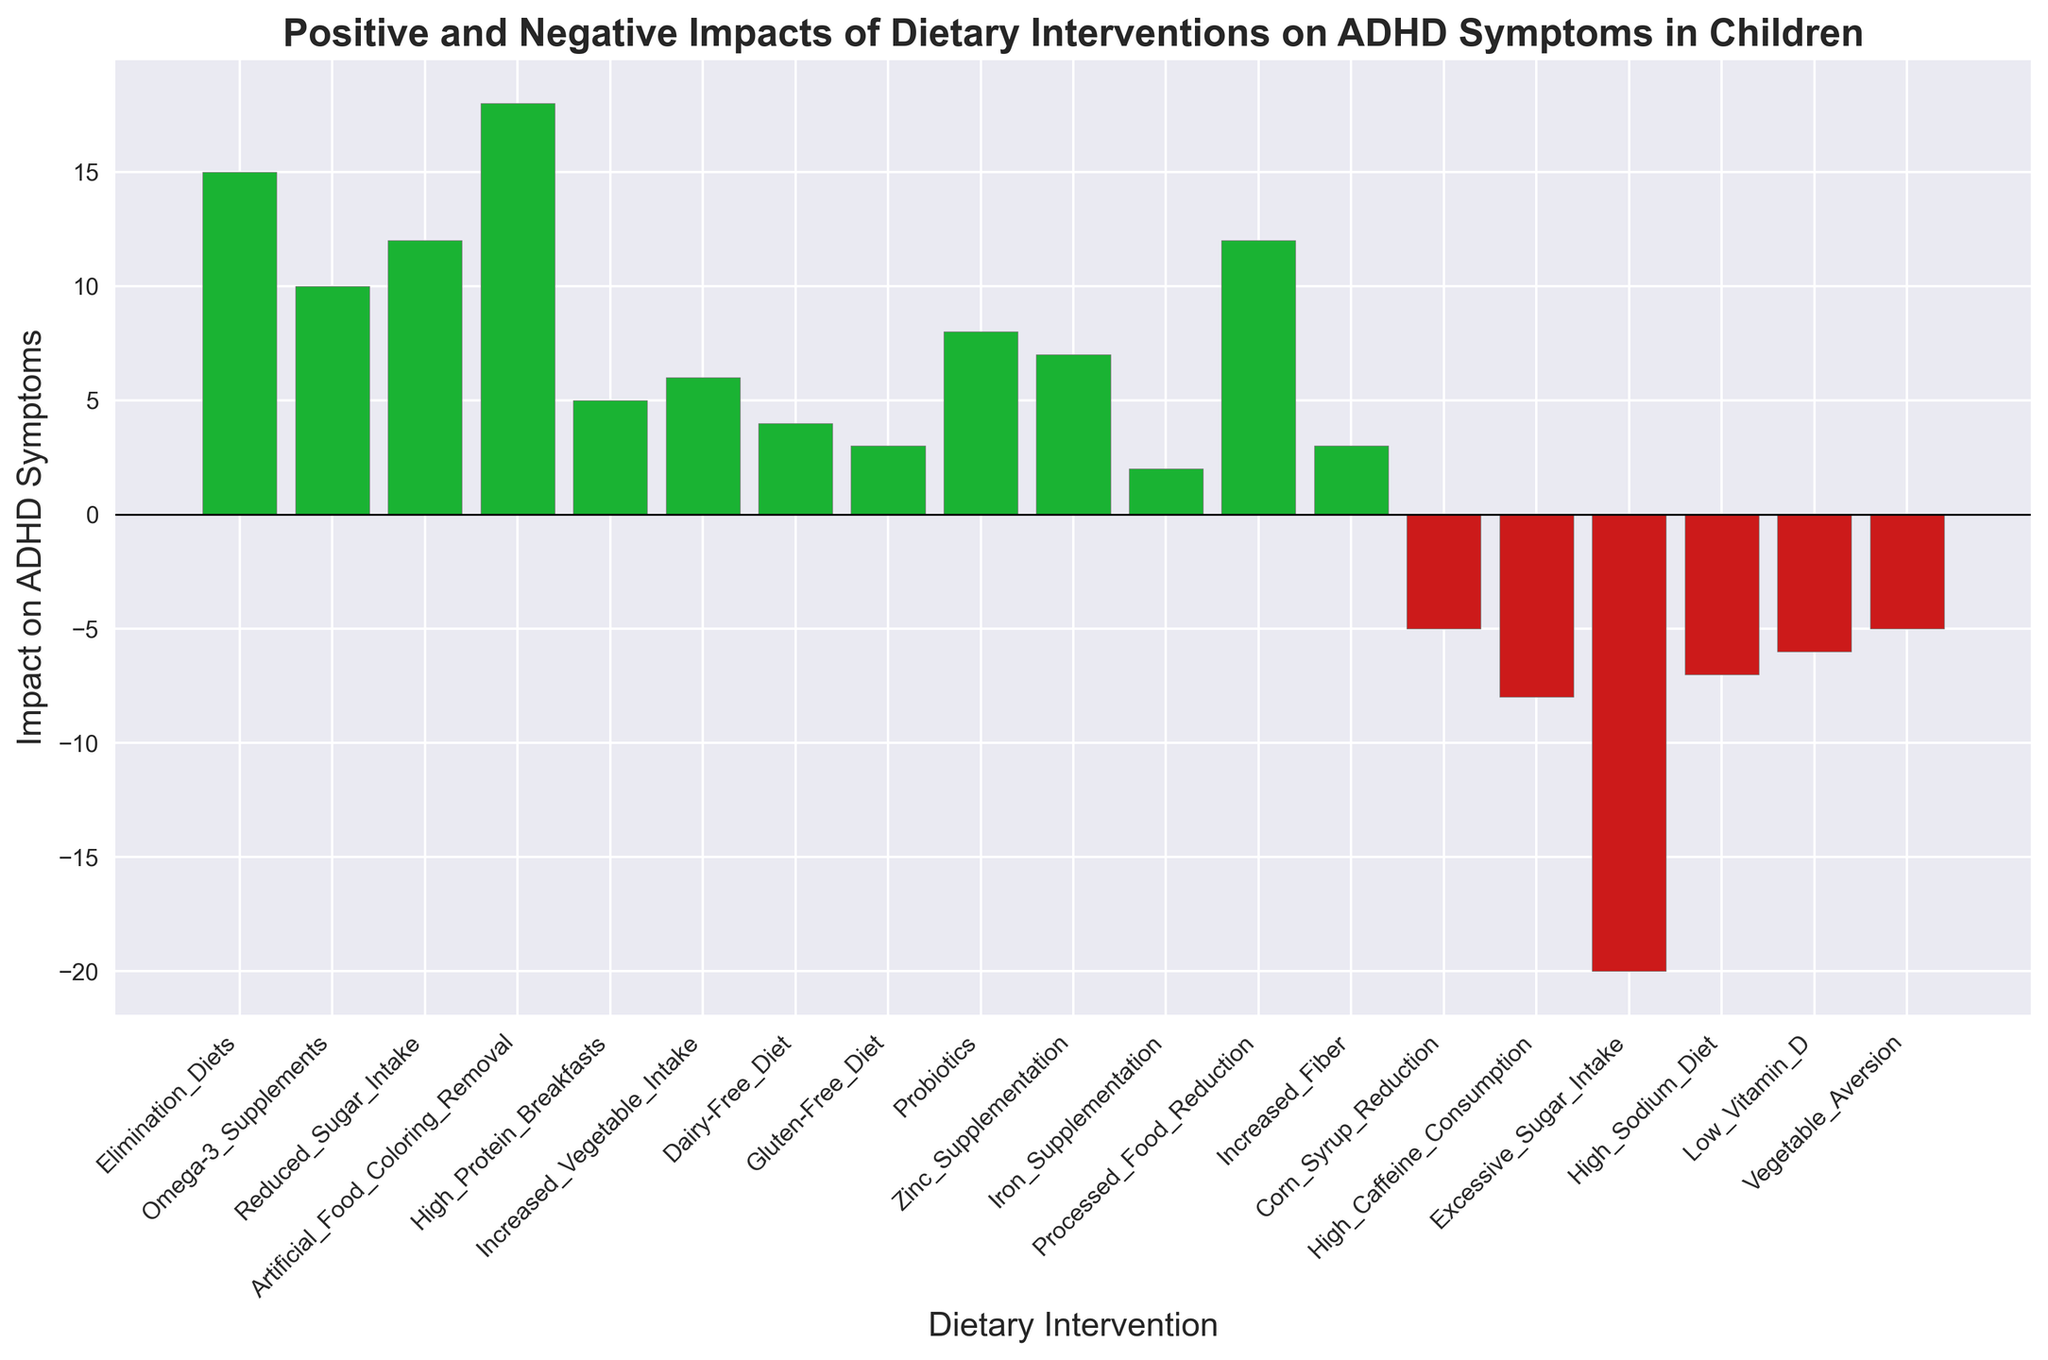Which dietary intervention has the highest positive impact on ADHD symptoms? The bar representing "Artificial Food Coloring Removal" is the highest and green, indicating the most positive impact.
Answer: Artificial Food Coloring Removal Which dietary intervention has the most negative impact on ADHD symptoms? The bar representing "Excessive Sugar Intake" is the lowest and red, indicating the most negative impact.
Answer: Excessive Sugar Intake What is the difference in impact between "Omega-3 Supplements" and "High Caffeine Consumption"? The bar for "Omega-3 Supplements" is at 10, and the bar for "High Caffeine Consumption" is at -8. The difference is 10 - (-8) = 18.
Answer: 18 Which interventions have an impact of less than 0 on ADHD symptoms? The red bars represent negative values: "Corn Syrup Reduction", "High Caffeine Consumption", "Excessive Sugar Intake", "High Sodium Diet", "Low Vitamin D", and "Vegetable Aversion".
Answer: Corn Syrup Reduction, High Caffeine Consumption, Excessive Sugar Intake, High Sodium Diet, Low Vitamin D, Vegetable Aversion How many interventions have a positive impact on ADHD symptoms? Count the green bars which represent positive values: "Elimination Diets", "Omega-3 Supplements", "Reduced Sugar Intake", "Artificial Food Coloring Removal", "High Protein Breakfasts", "Increased Vegetable Intake", "Dairy-Free Diet", "Gluten-Free Diet", "Probiotics", "Zinc Supplementation", "Iron Supplementation", "Processed Food Reduction", and "Increased Fiber".
Answer: 13 What is the combined impact of "Artificial Food Coloring Removal", "Reduced Sugar Intake", and "Processed Food Reduction"? The impacts are 18, 12, and 12 respectively. Their combined impact is 18 + 12 + 12 = 42.
Answer: 42 Are "High Protein Breakfasts" and "Zinc Supplementation" positive or negative interventions for ADHD symptoms? Both bars are green and above the zero line, indicating a positive impact.
Answer: Positive Which intervention is closest to having no impact? "Iron Supplementation" has an impact value of 2, making it the closest to zero.
Answer: Iron Supplementation Which intervention has a higher impact on ADHD symptoms: "Dairy-Free Diet" or "Increased Vegetable Intake"? "Increased Vegetable Intake" has an impact value of 6, while "Dairy-Free Diet" has an impact value of 4. 6 > 4
Answer: Increased Vegetable Intake What is the average positive impact among all positive dietary interventions? Positive impacts are 15, 10, 12, 18, 5, 6, 4, 3, 8, 7, 2, 12, and 3. The sum is 105, and there are 13 interventions. The average is 105 / 13 ≈ 8.08.
Answer: 8.08 